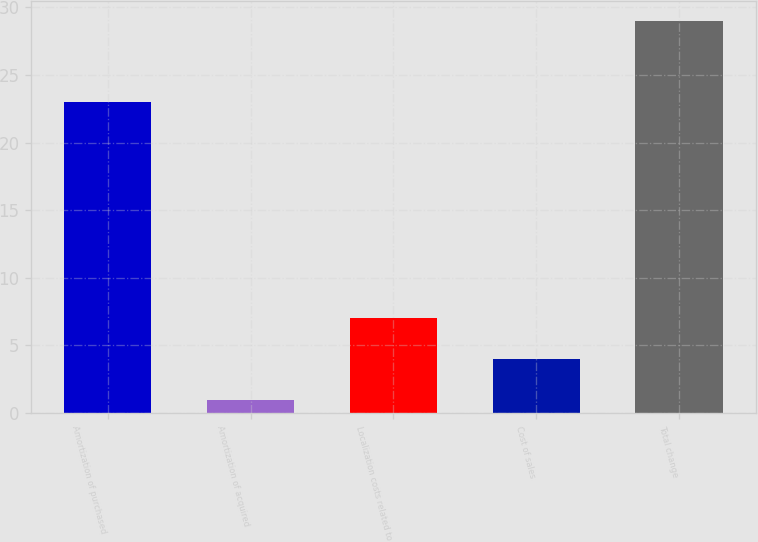Convert chart to OTSL. <chart><loc_0><loc_0><loc_500><loc_500><bar_chart><fcel>Amortization of purchased<fcel>Amortization of acquired<fcel>Localization costs related to<fcel>Cost of sales<fcel>Total change<nl><fcel>23<fcel>1<fcel>7<fcel>4<fcel>29<nl></chart> 